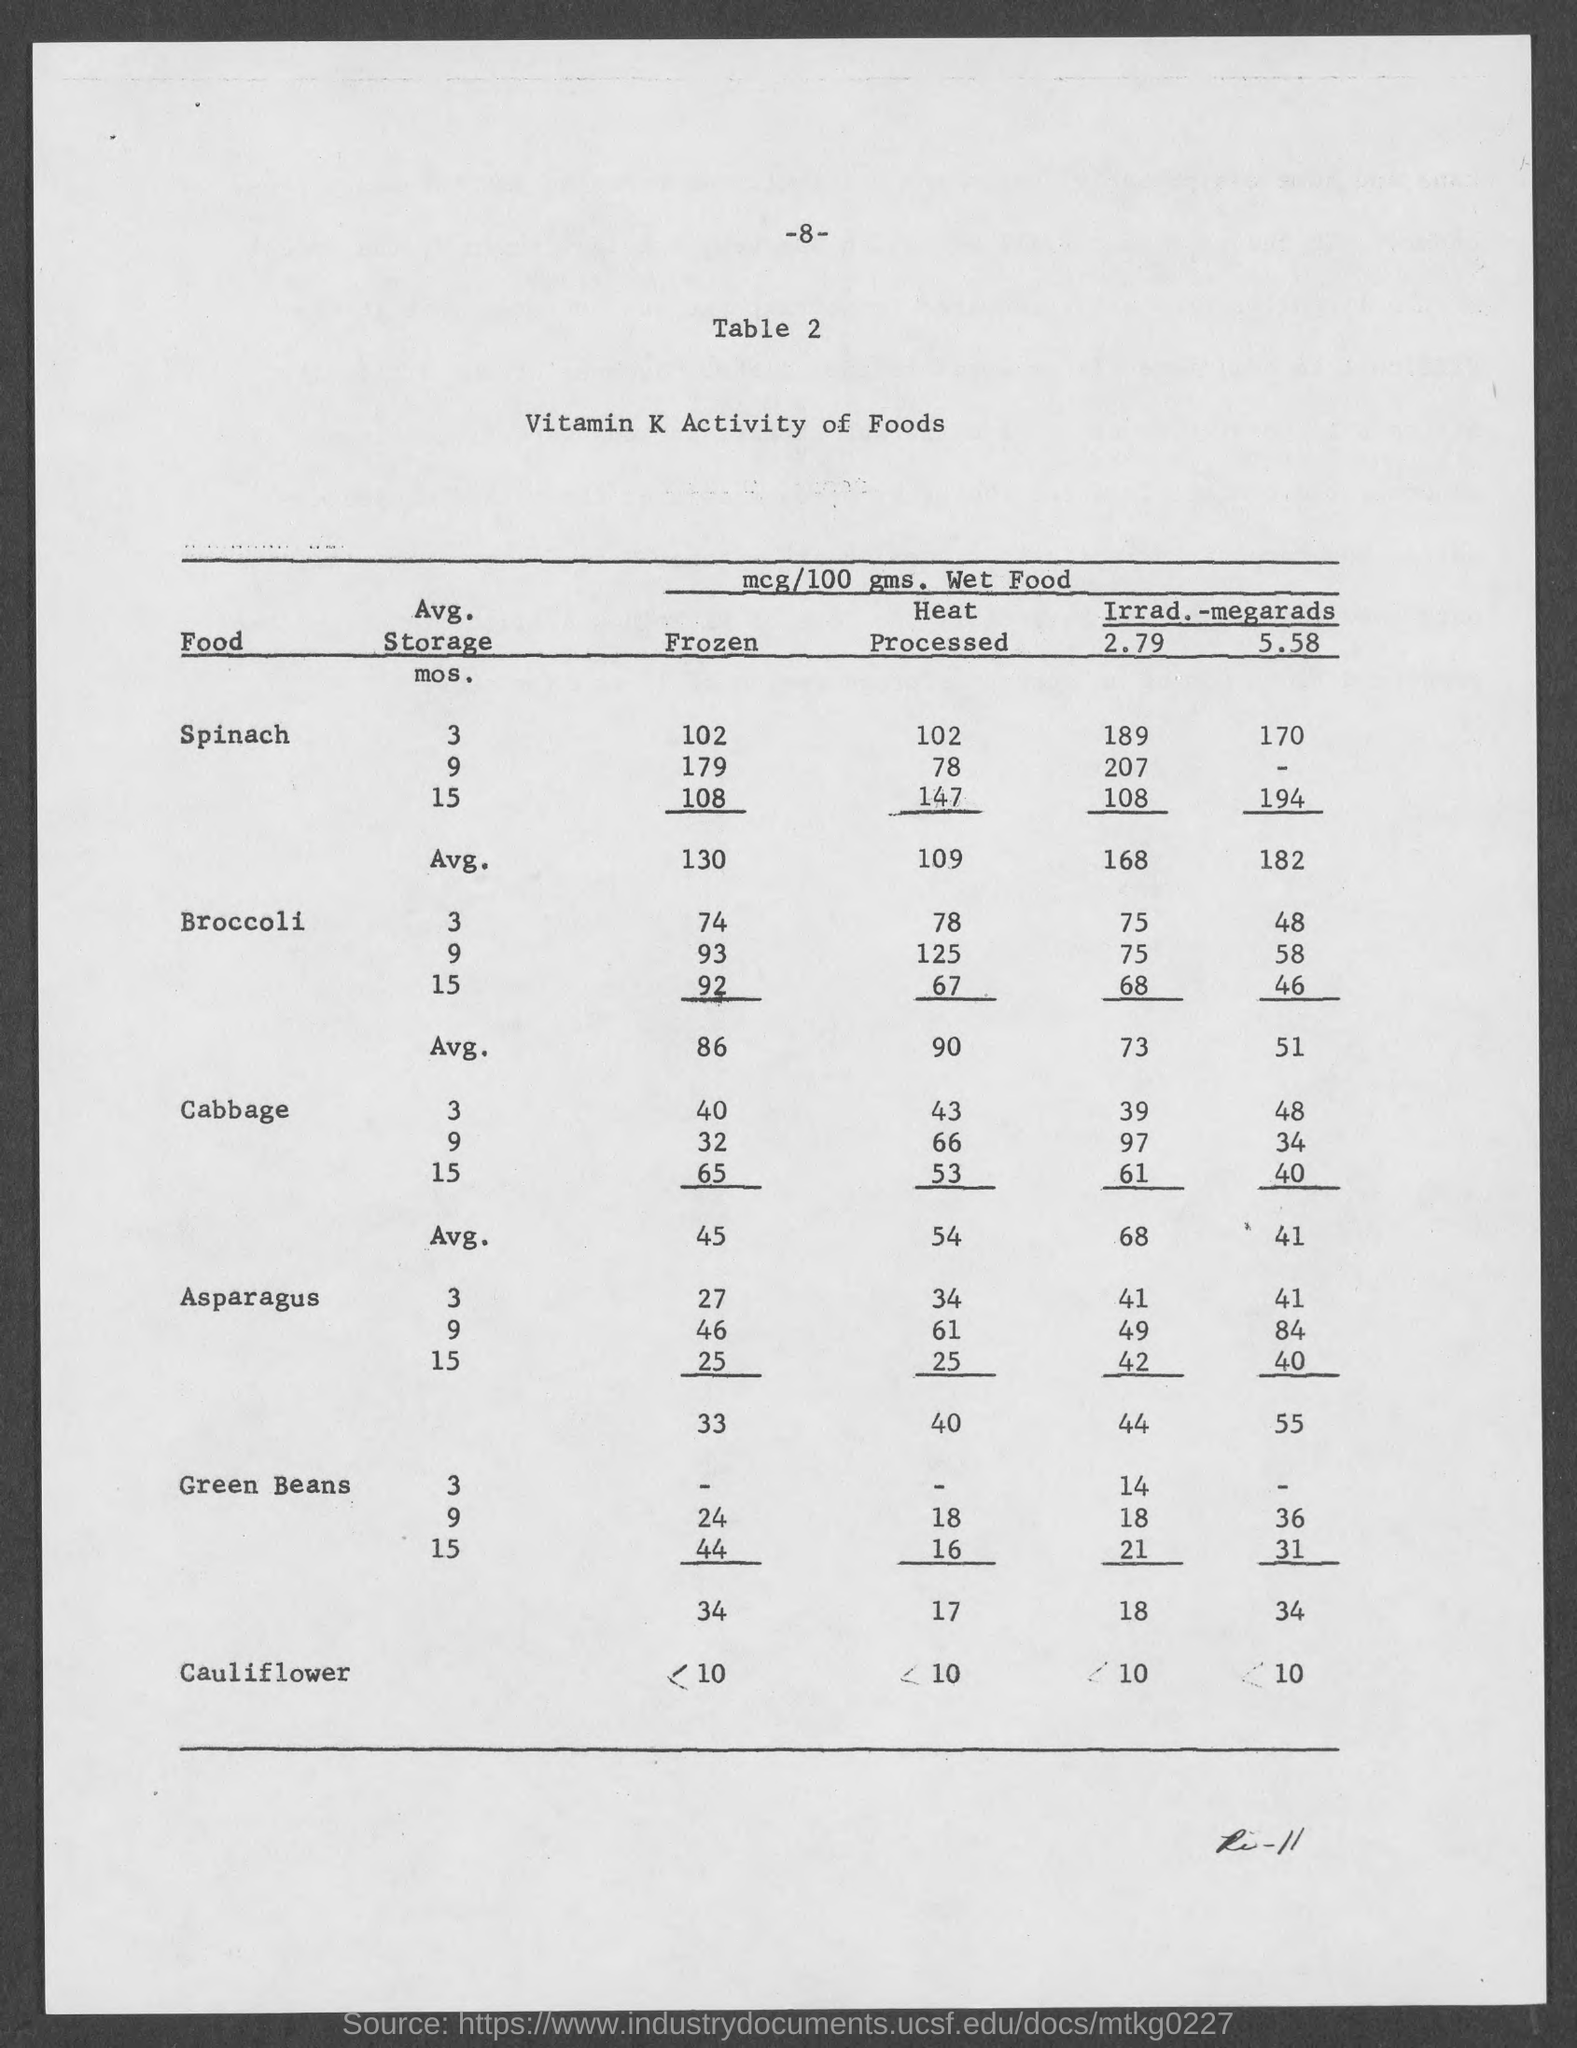Indicate a few pertinent items in this graphic. The page number at the top of the page is 8. The title of the table is 'Vitamin K activity of Foods.' 